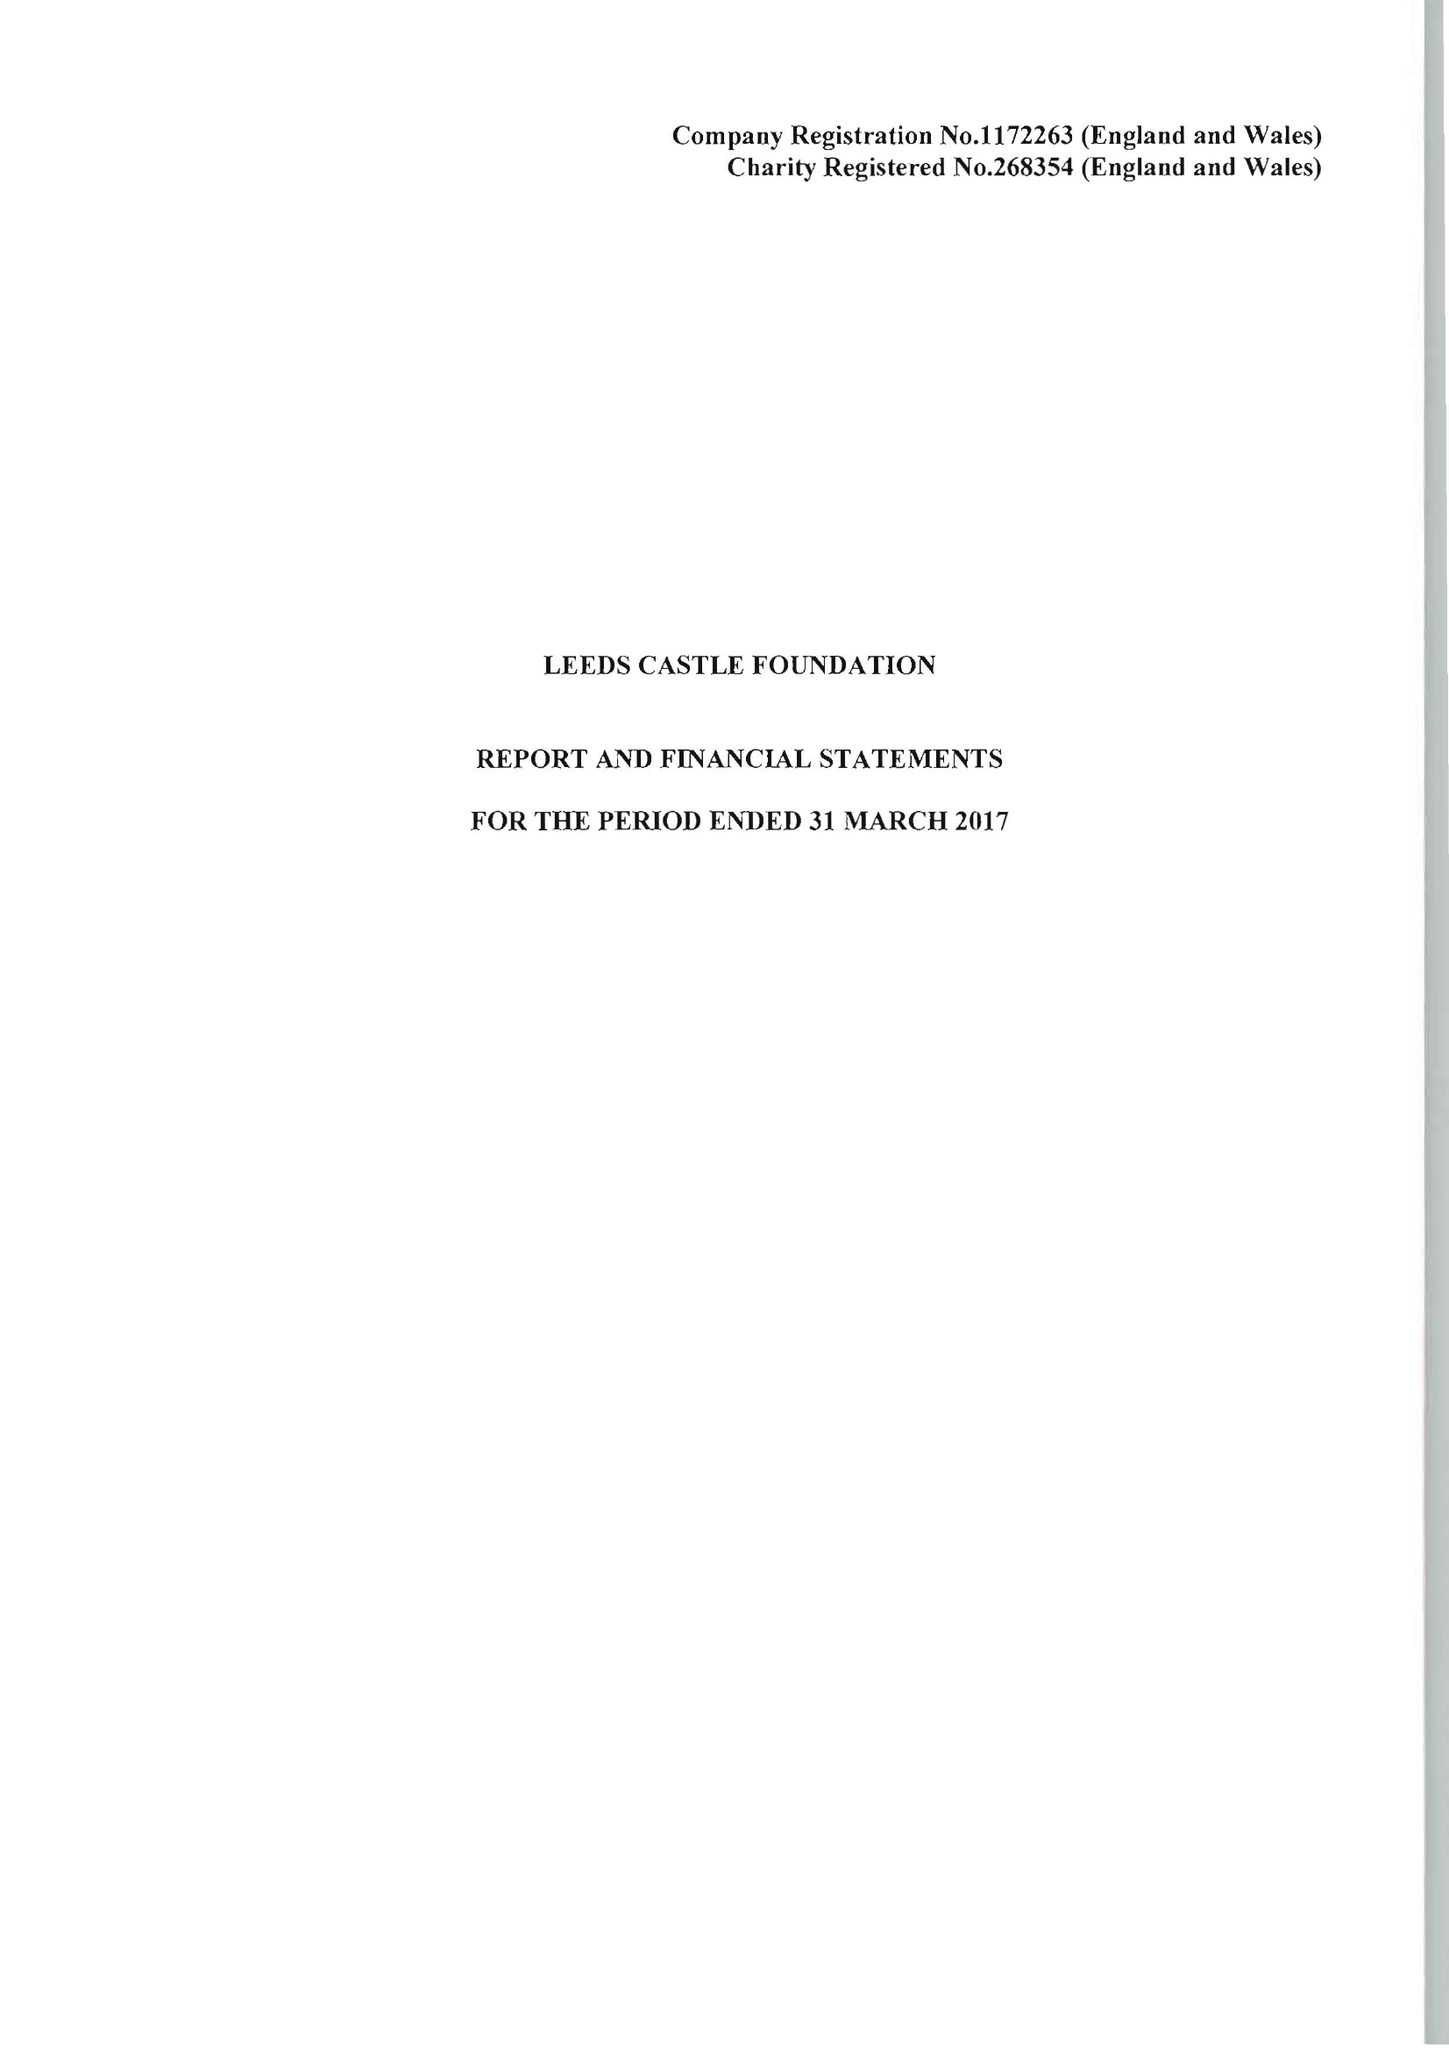What is the value for the address__post_town?
Answer the question using a single word or phrase. MAIDSTONE 